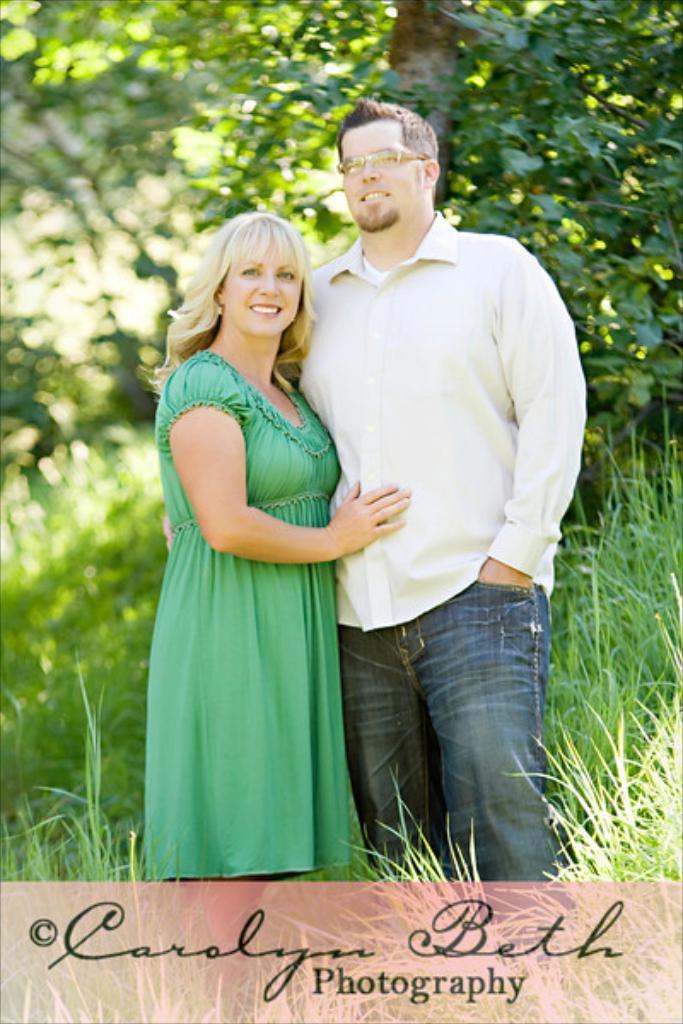Describe this image in one or two sentences. It is an edited image, there is a couple standing in between the grass and behind the couple there are many trees. 